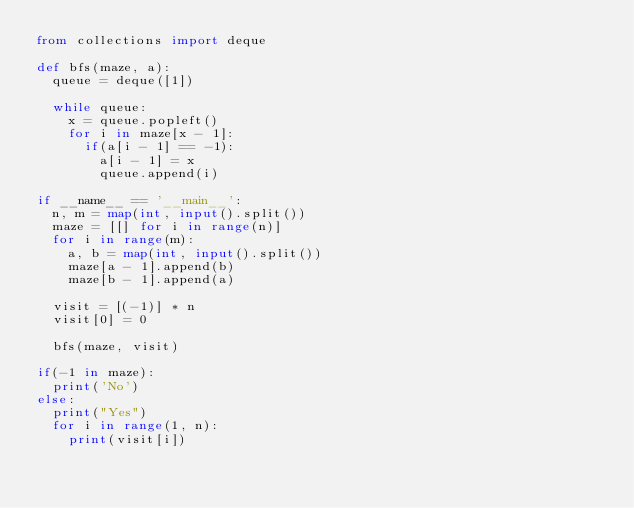Convert code to text. <code><loc_0><loc_0><loc_500><loc_500><_Python_>from collections import deque

def bfs(maze, a):
  queue = deque([1])

  while queue:
    x = queue.popleft()
    for i in maze[x - 1]:
      if(a[i - 1] == -1):
        a[i - 1] = x
        queue.append(i)
      
if __name__ == '__main__':
  n, m = map(int, input().split())
  maze = [[] for i in range(n)]
  for i in range(m):
    a, b = map(int, input().split())
    maze[a - 1].append(b)
    maze[b - 1].append(a)

  visit = [(-1)] * n
  visit[0] = 0

  bfs(maze, visit)

if(-1 in maze):
  print('No')
else:
  print("Yes")
  for i in range(1, n):
    print(visit[i])
</code> 